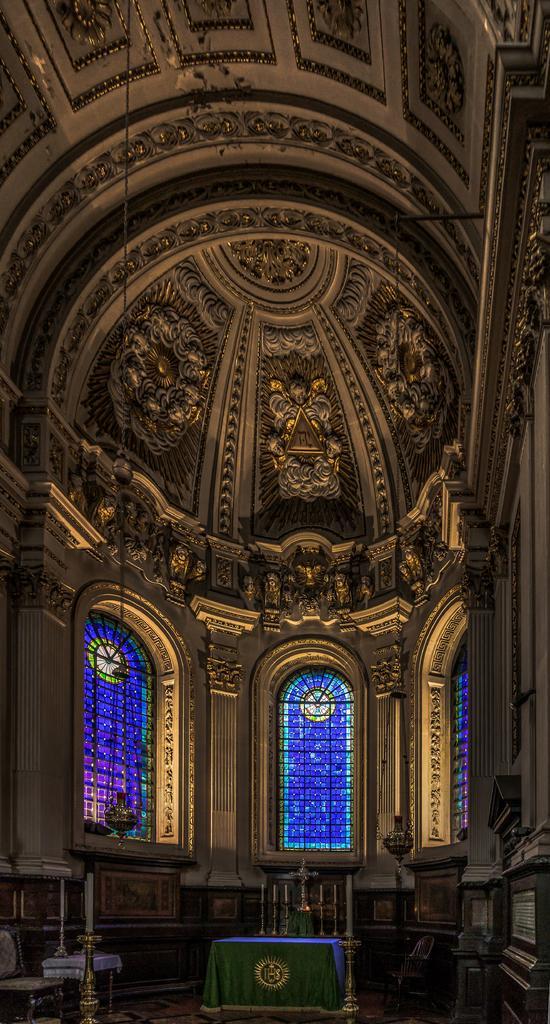Describe this image in one or two sentences. In this picture I can see the inside view of a building. In the background I see the glass windows and on the bottom of this picture I see few things. 